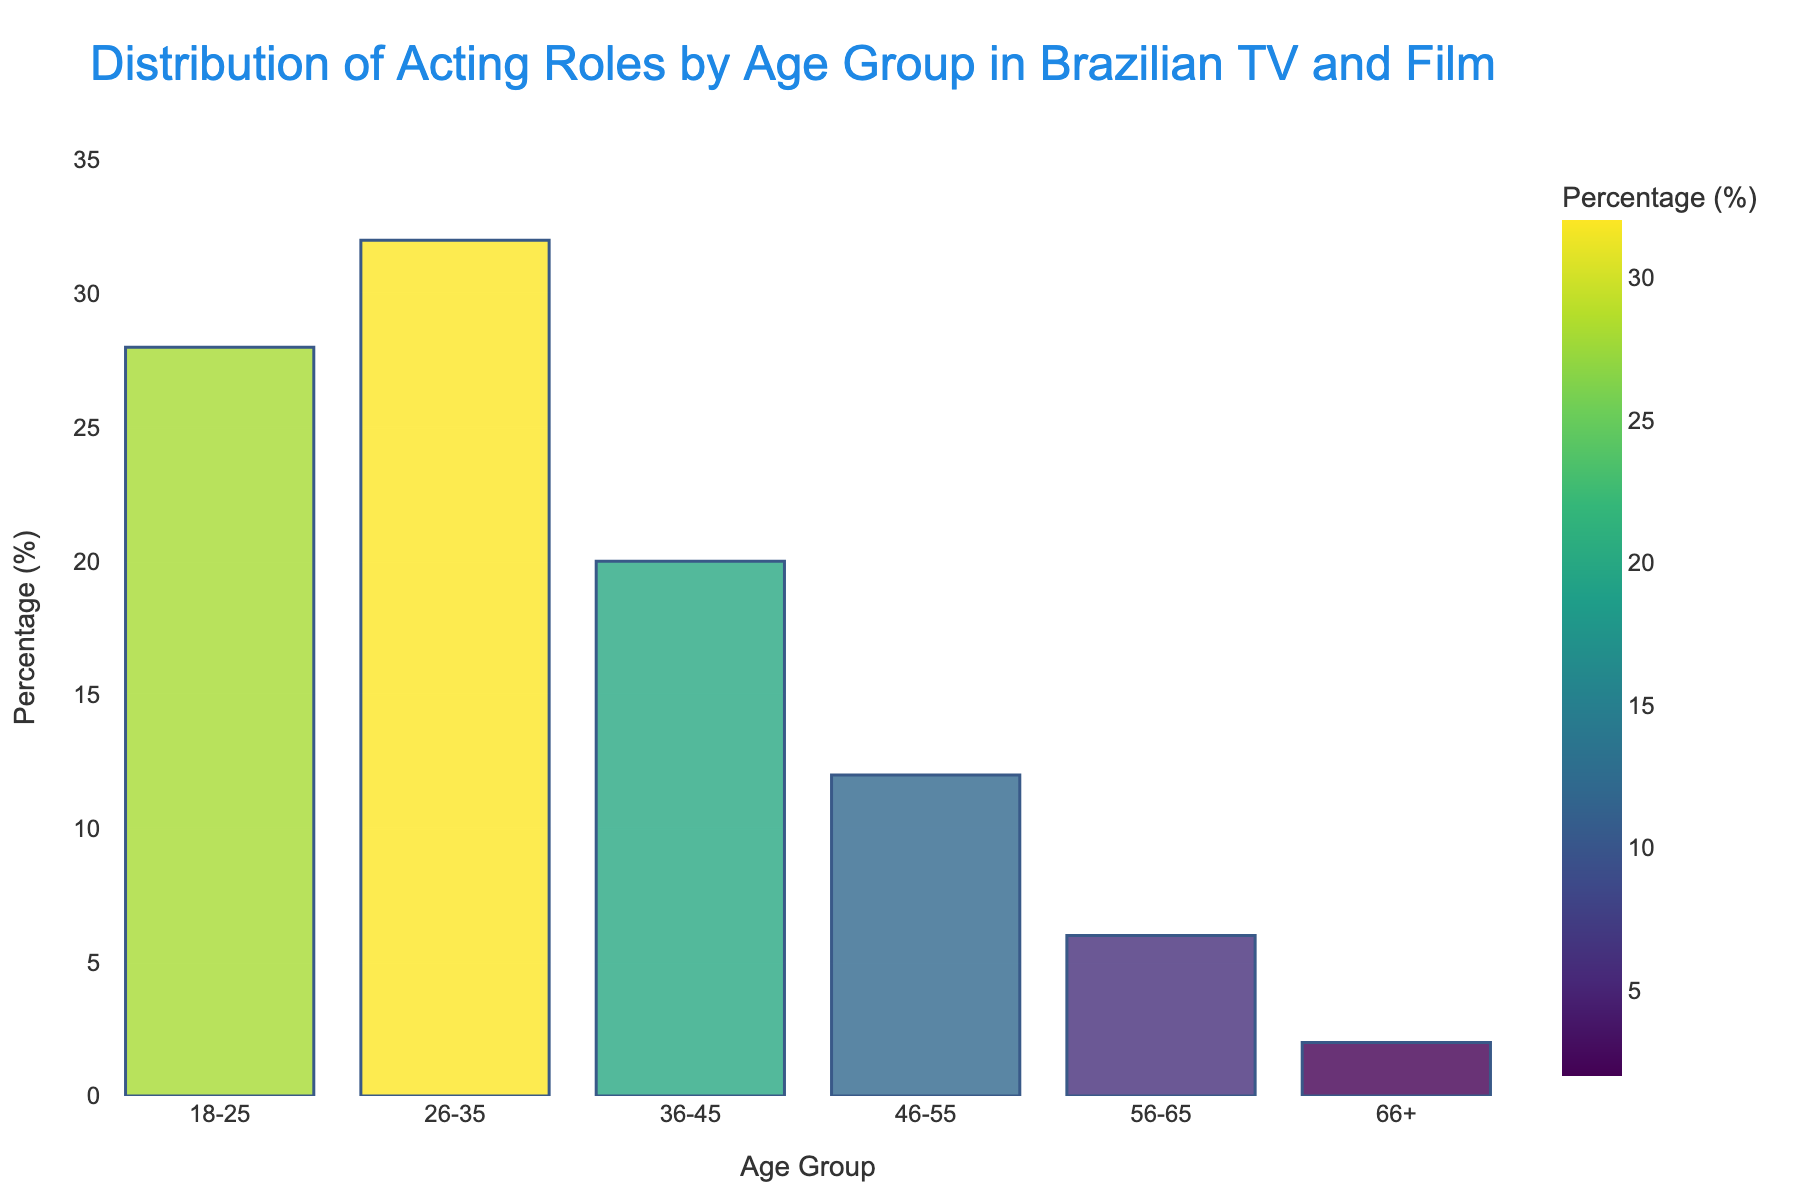What age group has the highest percentage of acting roles? The bar representing the age group 26-35 is the tallest, indicating it has the highest percentage of roles.
Answer: 26-35 Which age group has the lowest percentage of acting roles? The bar for the 66+ age group is the shortest, indicating it has the lowest percentage of roles.
Answer: 66+ How much more percentage of roles does the age group 18-25 have compared to the age group 56-65? The percentage of roles for the 18-25 age group is 28%, and for the 56-65 age group, it is 6%. The difference is calculated as 28% - 6% = 22%.
Answer: 22% What is the total percentage of roles for the age groups 36-45 and 46-55 combined? The percentage of roles for the 36-45 age group is 20%, and for the 46-55 age group, it is 12%. Adding these together gives 20% + 12% = 32%.
Answer: 32% Compare the percentage of acting roles between the age groups 26-35 and 56-65. The percentage of roles for the 26-35 age group is 32%, and for the 56-65 age group, it is 6%. 32% is significantly higher than 6%.
Answer: The 26-35 age group has a higher percentage of roles Which two adjacent age groups have the smallest difference in acting roles percentage? The smallest difference between adjacent age groups is between the 46-55 (12%) and 56-65 (6%), with a difference of 6%.
Answer: 46-55 and 56-65 By how much does the percentage of roles for the 26-35 age group exceed the average percentage of all other age groups? The sum of the percentages for the other age groups (18-25, 36-45, 46-55, 56-65, 66+) is 68%, and the average is 68% / 5 = 13.6%. The percentage for the 26-35 age group is 32%. The excess is calculated as 32% - 13.6% = 18.4%.
Answer: 18.4% What is the average percentage of acting roles across all age groups? The sum of all percentages is 100% (18-25: 28%, 26-35: 32%, 36-45: 20%, 46-55: 12%, 56-65: 6%, 66+: 2%), divided by 6 age groups, which gives 100% / 6 ≈ 16.67%.
Answer: 16.67% Is there an age group with exactly half the percentage of roles as the age group 26-35? The percentage of roles for the 26-35 age group is 32%. Half of this percentage is 16%. None of the age groups have exactly 16%.
Answer: No 